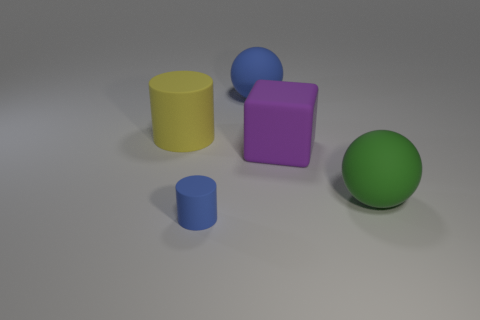What texture differences are there between the objects? Distinct texture differences are noticeable among the objects. The blue ball and the purple cube have matte surfaces, which diffusely reflect light, whereas the yellow and small blue cylinders appear to have a slightly shiny, rubber-like texture, with a bit more specular reflection. 